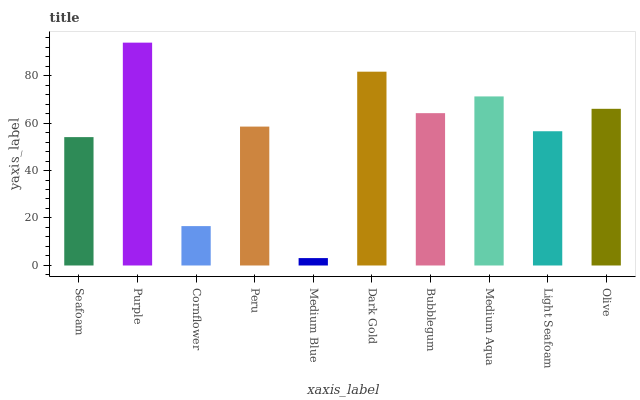Is Medium Blue the minimum?
Answer yes or no. Yes. Is Purple the maximum?
Answer yes or no. Yes. Is Cornflower the minimum?
Answer yes or no. No. Is Cornflower the maximum?
Answer yes or no. No. Is Purple greater than Cornflower?
Answer yes or no. Yes. Is Cornflower less than Purple?
Answer yes or no. Yes. Is Cornflower greater than Purple?
Answer yes or no. No. Is Purple less than Cornflower?
Answer yes or no. No. Is Bubblegum the high median?
Answer yes or no. Yes. Is Peru the low median?
Answer yes or no. Yes. Is Purple the high median?
Answer yes or no. No. Is Medium Aqua the low median?
Answer yes or no. No. 